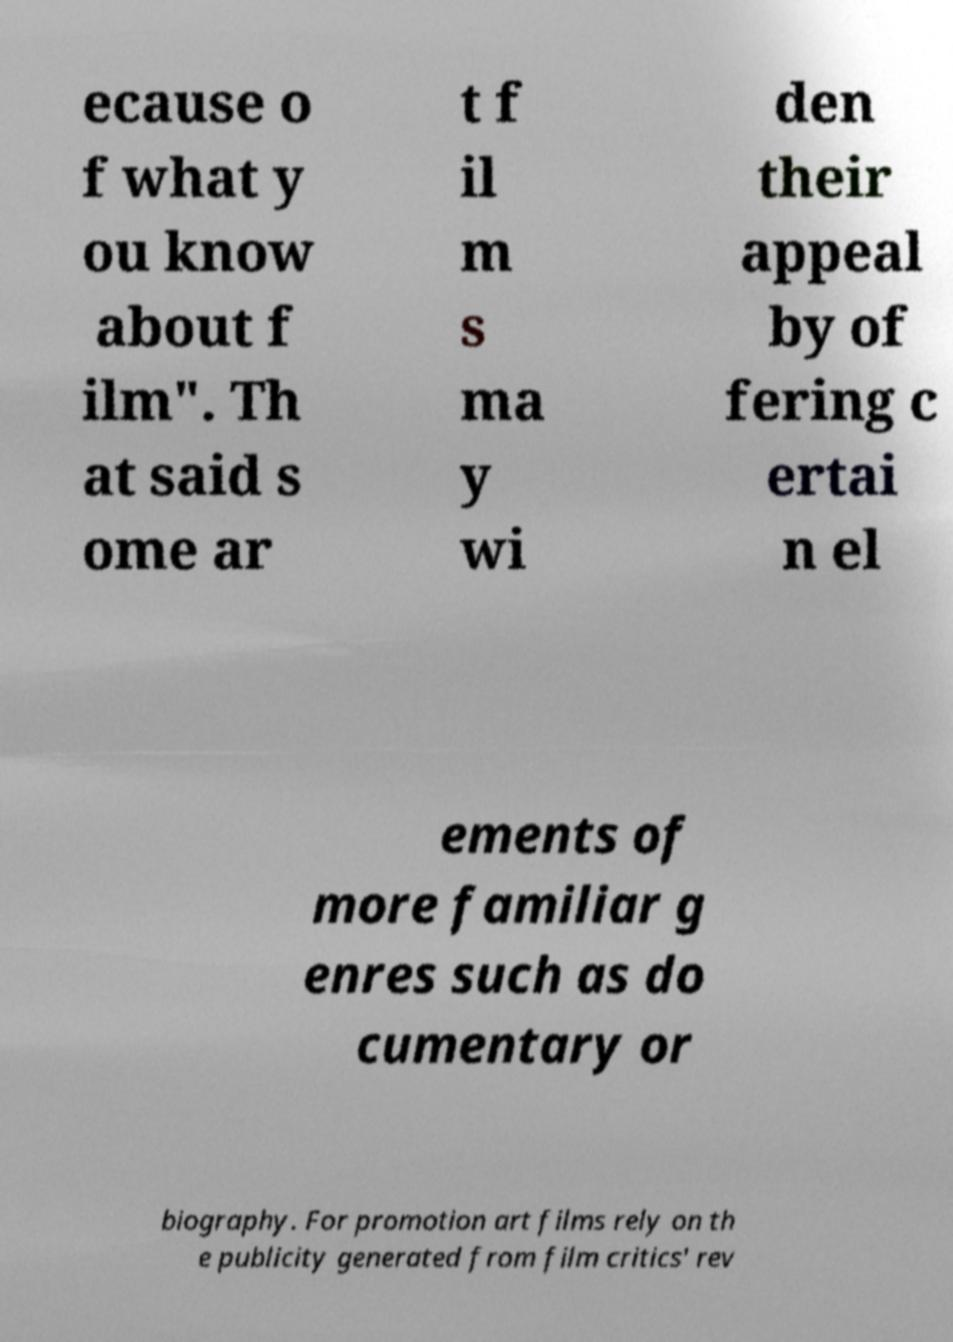For documentation purposes, I need the text within this image transcribed. Could you provide that? ecause o f what y ou know about f ilm". Th at said s ome ar t f il m s ma y wi den their appeal by of fering c ertai n el ements of more familiar g enres such as do cumentary or biography. For promotion art films rely on th e publicity generated from film critics' rev 